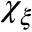Convert formula to latex. <formula><loc_0><loc_0><loc_500><loc_500>\chi _ { \xi }</formula> 